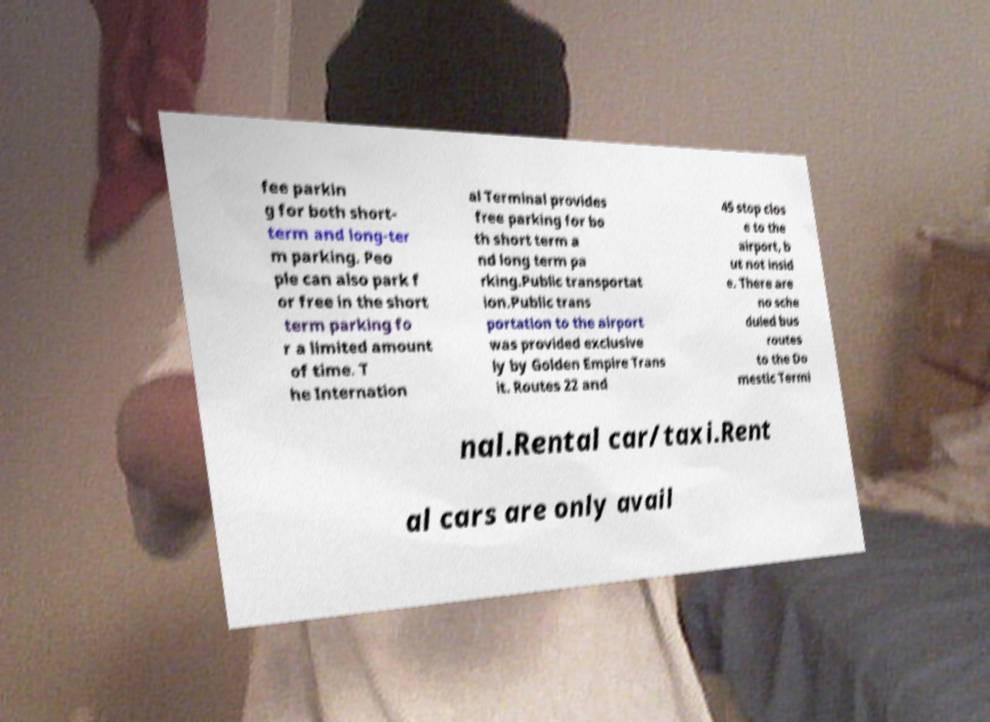Please identify and transcribe the text found in this image. fee parkin g for both short- term and long-ter m parking. Peo ple can also park f or free in the short term parking fo r a limited amount of time. T he Internation al Terminal provides free parking for bo th short term a nd long term pa rking.Public transportat ion.Public trans portation to the airport was provided exclusive ly by Golden Empire Trans it. Routes 22 and 45 stop clos e to the airport, b ut not insid e. There are no sche duled bus routes to the Do mestic Termi nal.Rental car/taxi.Rent al cars are only avail 